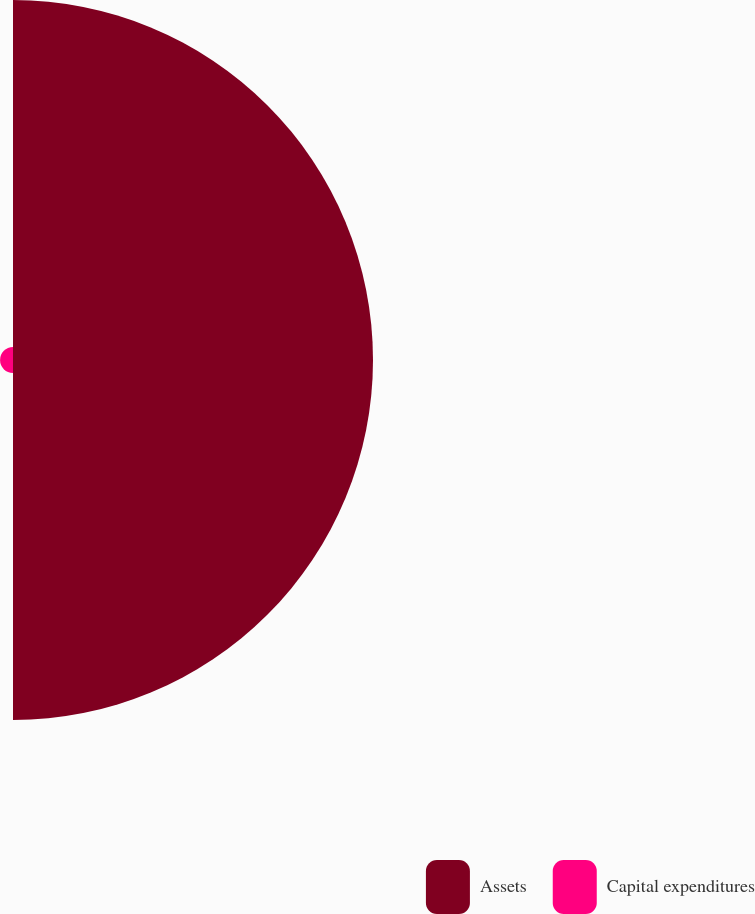Convert chart. <chart><loc_0><loc_0><loc_500><loc_500><pie_chart><fcel>Assets<fcel>Capital expenditures<nl><fcel>96.53%<fcel>3.47%<nl></chart> 